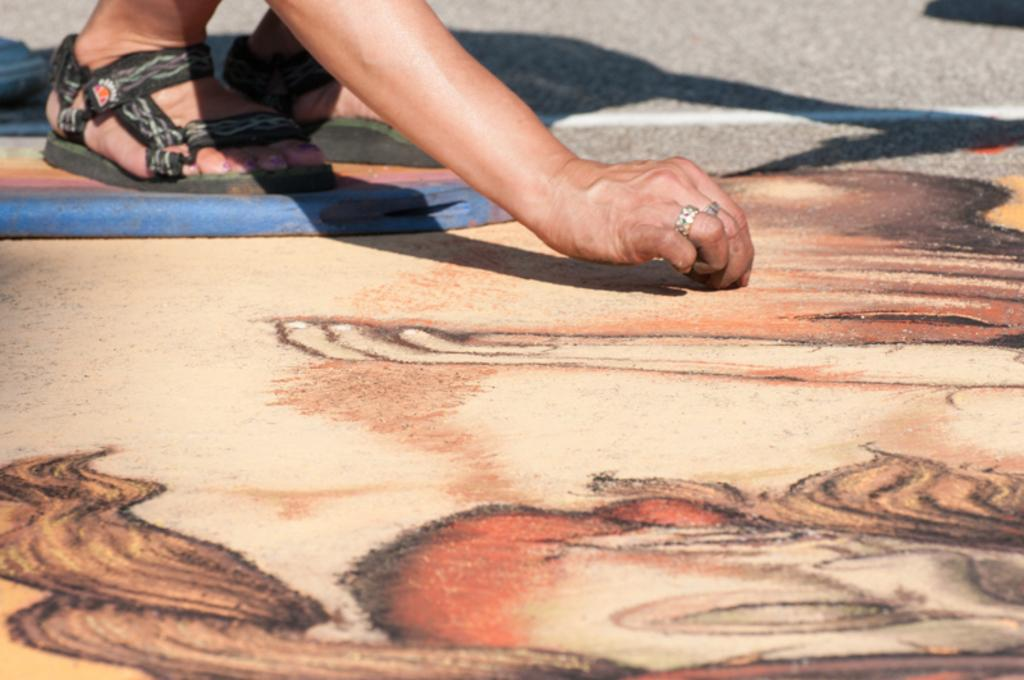Who or what is present in the image? There is a person in the image. What type of footwear is the person wearing? The person is wearing sandals. Are there any accessories visible on the person? Yes, the person is wearing finger rings. What type of artwork can be seen in the image? There is Rangoli in the image. What type of pathway is visible in the image? There is a road in the image. What flavor of coat is the person wearing in the image? There is no coat present in the image, and therefore no flavor can be determined. 